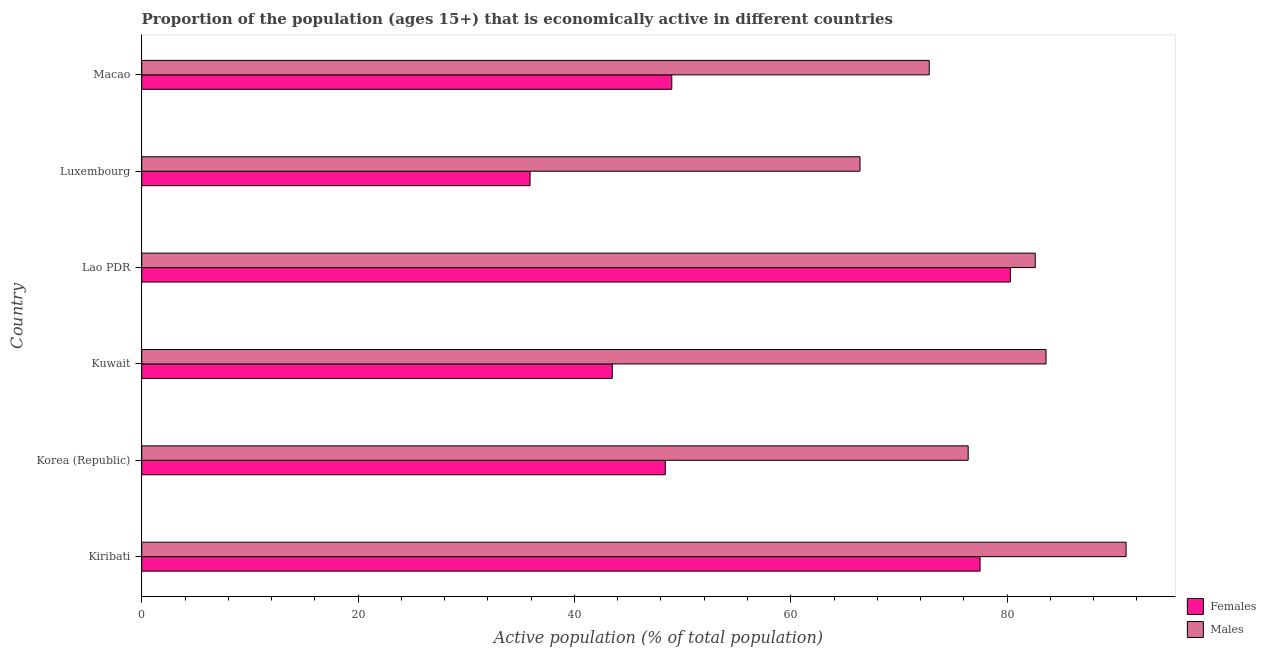How many groups of bars are there?
Your answer should be very brief. 6. Are the number of bars on each tick of the Y-axis equal?
Offer a very short reply. Yes. How many bars are there on the 3rd tick from the top?
Offer a very short reply. 2. How many bars are there on the 5th tick from the bottom?
Your answer should be compact. 2. What is the label of the 6th group of bars from the top?
Your answer should be compact. Kiribati. In how many cases, is the number of bars for a given country not equal to the number of legend labels?
Your response must be concise. 0. What is the percentage of economically active male population in Kiribati?
Offer a very short reply. 91. Across all countries, what is the maximum percentage of economically active female population?
Your answer should be very brief. 80.3. Across all countries, what is the minimum percentage of economically active male population?
Keep it short and to the point. 66.4. In which country was the percentage of economically active male population maximum?
Offer a terse response. Kiribati. In which country was the percentage of economically active male population minimum?
Your answer should be very brief. Luxembourg. What is the total percentage of economically active male population in the graph?
Offer a very short reply. 472.8. What is the difference between the percentage of economically active male population in Korea (Republic) and the percentage of economically active female population in Lao PDR?
Your response must be concise. -3.9. What is the average percentage of economically active female population per country?
Your answer should be compact. 55.77. What is the difference between the percentage of economically active female population and percentage of economically active male population in Korea (Republic)?
Keep it short and to the point. -28. What is the ratio of the percentage of economically active female population in Kiribati to that in Macao?
Offer a very short reply. 1.58. Is the percentage of economically active female population in Kiribati less than that in Macao?
Keep it short and to the point. No. What is the difference between the highest and the second highest percentage of economically active male population?
Make the answer very short. 7.4. What is the difference between the highest and the lowest percentage of economically active male population?
Your answer should be compact. 24.6. In how many countries, is the percentage of economically active male population greater than the average percentage of economically active male population taken over all countries?
Provide a succinct answer. 3. Is the sum of the percentage of economically active female population in Lao PDR and Macao greater than the maximum percentage of economically active male population across all countries?
Your answer should be compact. Yes. What does the 2nd bar from the top in Lao PDR represents?
Provide a short and direct response. Females. What does the 2nd bar from the bottom in Macao represents?
Your response must be concise. Males. How many bars are there?
Ensure brevity in your answer.  12. Are all the bars in the graph horizontal?
Make the answer very short. Yes. What is the difference between two consecutive major ticks on the X-axis?
Provide a short and direct response. 20. Are the values on the major ticks of X-axis written in scientific E-notation?
Your answer should be compact. No. Does the graph contain grids?
Offer a terse response. No. Where does the legend appear in the graph?
Ensure brevity in your answer.  Bottom right. How many legend labels are there?
Offer a very short reply. 2. How are the legend labels stacked?
Your answer should be very brief. Vertical. What is the title of the graph?
Your answer should be very brief. Proportion of the population (ages 15+) that is economically active in different countries. What is the label or title of the X-axis?
Provide a succinct answer. Active population (% of total population). What is the label or title of the Y-axis?
Your response must be concise. Country. What is the Active population (% of total population) in Females in Kiribati?
Keep it short and to the point. 77.5. What is the Active population (% of total population) in Males in Kiribati?
Offer a very short reply. 91. What is the Active population (% of total population) in Females in Korea (Republic)?
Your answer should be very brief. 48.4. What is the Active population (% of total population) of Males in Korea (Republic)?
Ensure brevity in your answer.  76.4. What is the Active population (% of total population) of Females in Kuwait?
Your answer should be compact. 43.5. What is the Active population (% of total population) in Males in Kuwait?
Offer a very short reply. 83.6. What is the Active population (% of total population) in Females in Lao PDR?
Ensure brevity in your answer.  80.3. What is the Active population (% of total population) of Males in Lao PDR?
Make the answer very short. 82.6. What is the Active population (% of total population) of Females in Luxembourg?
Give a very brief answer. 35.9. What is the Active population (% of total population) in Males in Luxembourg?
Make the answer very short. 66.4. What is the Active population (% of total population) in Males in Macao?
Your answer should be very brief. 72.8. Across all countries, what is the maximum Active population (% of total population) of Females?
Provide a short and direct response. 80.3. Across all countries, what is the maximum Active population (% of total population) of Males?
Give a very brief answer. 91. Across all countries, what is the minimum Active population (% of total population) of Females?
Provide a succinct answer. 35.9. Across all countries, what is the minimum Active population (% of total population) of Males?
Offer a terse response. 66.4. What is the total Active population (% of total population) in Females in the graph?
Your answer should be very brief. 334.6. What is the total Active population (% of total population) of Males in the graph?
Your answer should be compact. 472.8. What is the difference between the Active population (% of total population) of Females in Kiribati and that in Korea (Republic)?
Offer a very short reply. 29.1. What is the difference between the Active population (% of total population) of Males in Kiribati and that in Korea (Republic)?
Give a very brief answer. 14.6. What is the difference between the Active population (% of total population) of Females in Kiribati and that in Lao PDR?
Provide a short and direct response. -2.8. What is the difference between the Active population (% of total population) of Females in Kiribati and that in Luxembourg?
Provide a succinct answer. 41.6. What is the difference between the Active population (% of total population) of Males in Kiribati and that in Luxembourg?
Your response must be concise. 24.6. What is the difference between the Active population (% of total population) of Females in Korea (Republic) and that in Kuwait?
Keep it short and to the point. 4.9. What is the difference between the Active population (% of total population) of Females in Korea (Republic) and that in Lao PDR?
Your response must be concise. -31.9. What is the difference between the Active population (% of total population) in Females in Korea (Republic) and that in Luxembourg?
Your answer should be compact. 12.5. What is the difference between the Active population (% of total population) in Males in Korea (Republic) and that in Luxembourg?
Ensure brevity in your answer.  10. What is the difference between the Active population (% of total population) in Females in Korea (Republic) and that in Macao?
Ensure brevity in your answer.  -0.6. What is the difference between the Active population (% of total population) of Females in Kuwait and that in Lao PDR?
Offer a very short reply. -36.8. What is the difference between the Active population (% of total population) in Males in Kuwait and that in Lao PDR?
Offer a terse response. 1. What is the difference between the Active population (% of total population) in Females in Kuwait and that in Luxembourg?
Your answer should be very brief. 7.6. What is the difference between the Active population (% of total population) in Males in Kuwait and that in Luxembourg?
Your answer should be very brief. 17.2. What is the difference between the Active population (% of total population) in Females in Kuwait and that in Macao?
Provide a short and direct response. -5.5. What is the difference between the Active population (% of total population) of Females in Lao PDR and that in Luxembourg?
Keep it short and to the point. 44.4. What is the difference between the Active population (% of total population) in Females in Lao PDR and that in Macao?
Give a very brief answer. 31.3. What is the difference between the Active population (% of total population) in Males in Lao PDR and that in Macao?
Your answer should be compact. 9.8. What is the difference between the Active population (% of total population) of Females in Kiribati and the Active population (% of total population) of Males in Korea (Republic)?
Your answer should be very brief. 1.1. What is the difference between the Active population (% of total population) of Females in Kiribati and the Active population (% of total population) of Males in Luxembourg?
Your answer should be very brief. 11.1. What is the difference between the Active population (% of total population) of Females in Kiribati and the Active population (% of total population) of Males in Macao?
Provide a short and direct response. 4.7. What is the difference between the Active population (% of total population) of Females in Korea (Republic) and the Active population (% of total population) of Males in Kuwait?
Offer a very short reply. -35.2. What is the difference between the Active population (% of total population) of Females in Korea (Republic) and the Active population (% of total population) of Males in Lao PDR?
Offer a very short reply. -34.2. What is the difference between the Active population (% of total population) in Females in Korea (Republic) and the Active population (% of total population) in Males in Macao?
Your answer should be compact. -24.4. What is the difference between the Active population (% of total population) in Females in Kuwait and the Active population (% of total population) in Males in Lao PDR?
Give a very brief answer. -39.1. What is the difference between the Active population (% of total population) in Females in Kuwait and the Active population (% of total population) in Males in Luxembourg?
Offer a very short reply. -22.9. What is the difference between the Active population (% of total population) of Females in Kuwait and the Active population (% of total population) of Males in Macao?
Offer a terse response. -29.3. What is the difference between the Active population (% of total population) of Females in Luxembourg and the Active population (% of total population) of Males in Macao?
Make the answer very short. -36.9. What is the average Active population (% of total population) in Females per country?
Provide a succinct answer. 55.77. What is the average Active population (% of total population) of Males per country?
Make the answer very short. 78.8. What is the difference between the Active population (% of total population) in Females and Active population (% of total population) in Males in Kiribati?
Offer a very short reply. -13.5. What is the difference between the Active population (% of total population) of Females and Active population (% of total population) of Males in Korea (Republic)?
Provide a short and direct response. -28. What is the difference between the Active population (% of total population) in Females and Active population (% of total population) in Males in Kuwait?
Your response must be concise. -40.1. What is the difference between the Active population (% of total population) in Females and Active population (% of total population) in Males in Lao PDR?
Your response must be concise. -2.3. What is the difference between the Active population (% of total population) in Females and Active population (% of total population) in Males in Luxembourg?
Provide a short and direct response. -30.5. What is the difference between the Active population (% of total population) of Females and Active population (% of total population) of Males in Macao?
Keep it short and to the point. -23.8. What is the ratio of the Active population (% of total population) of Females in Kiribati to that in Korea (Republic)?
Offer a very short reply. 1.6. What is the ratio of the Active population (% of total population) in Males in Kiribati to that in Korea (Republic)?
Ensure brevity in your answer.  1.19. What is the ratio of the Active population (% of total population) of Females in Kiribati to that in Kuwait?
Ensure brevity in your answer.  1.78. What is the ratio of the Active population (% of total population) of Males in Kiribati to that in Kuwait?
Your answer should be very brief. 1.09. What is the ratio of the Active population (% of total population) in Females in Kiribati to that in Lao PDR?
Provide a short and direct response. 0.97. What is the ratio of the Active population (% of total population) in Males in Kiribati to that in Lao PDR?
Your answer should be very brief. 1.1. What is the ratio of the Active population (% of total population) of Females in Kiribati to that in Luxembourg?
Your answer should be very brief. 2.16. What is the ratio of the Active population (% of total population) in Males in Kiribati to that in Luxembourg?
Ensure brevity in your answer.  1.37. What is the ratio of the Active population (% of total population) in Females in Kiribati to that in Macao?
Provide a short and direct response. 1.58. What is the ratio of the Active population (% of total population) of Females in Korea (Republic) to that in Kuwait?
Your response must be concise. 1.11. What is the ratio of the Active population (% of total population) of Males in Korea (Republic) to that in Kuwait?
Ensure brevity in your answer.  0.91. What is the ratio of the Active population (% of total population) of Females in Korea (Republic) to that in Lao PDR?
Offer a terse response. 0.6. What is the ratio of the Active population (% of total population) of Males in Korea (Republic) to that in Lao PDR?
Offer a terse response. 0.92. What is the ratio of the Active population (% of total population) of Females in Korea (Republic) to that in Luxembourg?
Offer a terse response. 1.35. What is the ratio of the Active population (% of total population) in Males in Korea (Republic) to that in Luxembourg?
Provide a succinct answer. 1.15. What is the ratio of the Active population (% of total population) in Males in Korea (Republic) to that in Macao?
Offer a terse response. 1.05. What is the ratio of the Active population (% of total population) of Females in Kuwait to that in Lao PDR?
Ensure brevity in your answer.  0.54. What is the ratio of the Active population (% of total population) of Males in Kuwait to that in Lao PDR?
Give a very brief answer. 1.01. What is the ratio of the Active population (% of total population) in Females in Kuwait to that in Luxembourg?
Provide a short and direct response. 1.21. What is the ratio of the Active population (% of total population) in Males in Kuwait to that in Luxembourg?
Provide a succinct answer. 1.26. What is the ratio of the Active population (% of total population) of Females in Kuwait to that in Macao?
Your response must be concise. 0.89. What is the ratio of the Active population (% of total population) of Males in Kuwait to that in Macao?
Ensure brevity in your answer.  1.15. What is the ratio of the Active population (% of total population) in Females in Lao PDR to that in Luxembourg?
Keep it short and to the point. 2.24. What is the ratio of the Active population (% of total population) of Males in Lao PDR to that in Luxembourg?
Give a very brief answer. 1.24. What is the ratio of the Active population (% of total population) in Females in Lao PDR to that in Macao?
Offer a terse response. 1.64. What is the ratio of the Active population (% of total population) of Males in Lao PDR to that in Macao?
Keep it short and to the point. 1.13. What is the ratio of the Active population (% of total population) in Females in Luxembourg to that in Macao?
Make the answer very short. 0.73. What is the ratio of the Active population (% of total population) of Males in Luxembourg to that in Macao?
Your answer should be compact. 0.91. What is the difference between the highest and the second highest Active population (% of total population) of Females?
Your answer should be compact. 2.8. What is the difference between the highest and the lowest Active population (% of total population) of Females?
Your answer should be very brief. 44.4. What is the difference between the highest and the lowest Active population (% of total population) of Males?
Your answer should be compact. 24.6. 